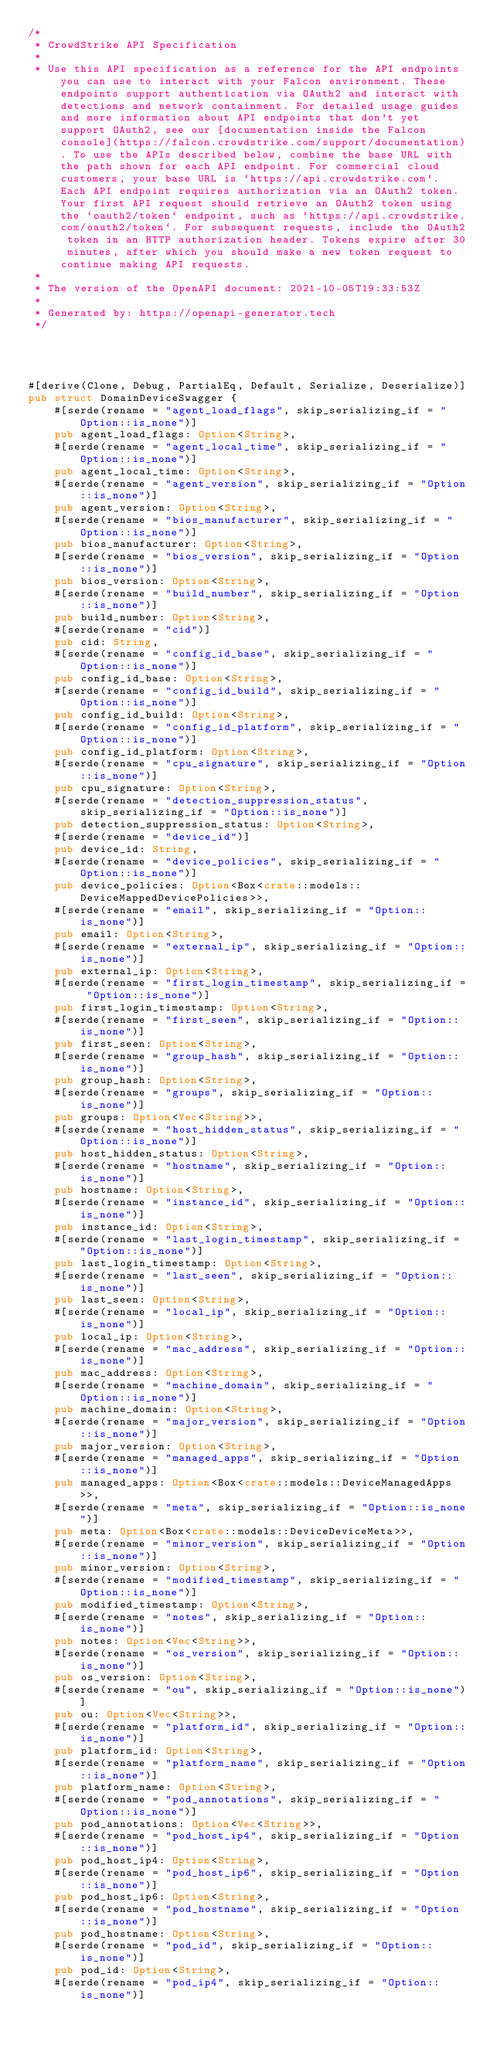Convert code to text. <code><loc_0><loc_0><loc_500><loc_500><_Rust_>/*
 * CrowdStrike API Specification
 *
 * Use this API specification as a reference for the API endpoints you can use to interact with your Falcon environment. These endpoints support authentication via OAuth2 and interact with detections and network containment. For detailed usage guides and more information about API endpoints that don't yet support OAuth2, see our [documentation inside the Falcon console](https://falcon.crowdstrike.com/support/documentation). To use the APIs described below, combine the base URL with the path shown for each API endpoint. For commercial cloud customers, your base URL is `https://api.crowdstrike.com`. Each API endpoint requires authorization via an OAuth2 token. Your first API request should retrieve an OAuth2 token using the `oauth2/token` endpoint, such as `https://api.crowdstrike.com/oauth2/token`. For subsequent requests, include the OAuth2 token in an HTTP authorization header. Tokens expire after 30 minutes, after which you should make a new token request to continue making API requests.
 *
 * The version of the OpenAPI document: 2021-10-05T19:33:53Z
 * 
 * Generated by: https://openapi-generator.tech
 */




#[derive(Clone, Debug, PartialEq, Default, Serialize, Deserialize)]
pub struct DomainDeviceSwagger {
    #[serde(rename = "agent_load_flags", skip_serializing_if = "Option::is_none")]
    pub agent_load_flags: Option<String>,
    #[serde(rename = "agent_local_time", skip_serializing_if = "Option::is_none")]
    pub agent_local_time: Option<String>,
    #[serde(rename = "agent_version", skip_serializing_if = "Option::is_none")]
    pub agent_version: Option<String>,
    #[serde(rename = "bios_manufacturer", skip_serializing_if = "Option::is_none")]
    pub bios_manufacturer: Option<String>,
    #[serde(rename = "bios_version", skip_serializing_if = "Option::is_none")]
    pub bios_version: Option<String>,
    #[serde(rename = "build_number", skip_serializing_if = "Option::is_none")]
    pub build_number: Option<String>,
    #[serde(rename = "cid")]
    pub cid: String,
    #[serde(rename = "config_id_base", skip_serializing_if = "Option::is_none")]
    pub config_id_base: Option<String>,
    #[serde(rename = "config_id_build", skip_serializing_if = "Option::is_none")]
    pub config_id_build: Option<String>,
    #[serde(rename = "config_id_platform", skip_serializing_if = "Option::is_none")]
    pub config_id_platform: Option<String>,
    #[serde(rename = "cpu_signature", skip_serializing_if = "Option::is_none")]
    pub cpu_signature: Option<String>,
    #[serde(rename = "detection_suppression_status", skip_serializing_if = "Option::is_none")]
    pub detection_suppression_status: Option<String>,
    #[serde(rename = "device_id")]
    pub device_id: String,
    #[serde(rename = "device_policies", skip_serializing_if = "Option::is_none")]
    pub device_policies: Option<Box<crate::models::DeviceMappedDevicePolicies>>,
    #[serde(rename = "email", skip_serializing_if = "Option::is_none")]
    pub email: Option<String>,
    #[serde(rename = "external_ip", skip_serializing_if = "Option::is_none")]
    pub external_ip: Option<String>,
    #[serde(rename = "first_login_timestamp", skip_serializing_if = "Option::is_none")]
    pub first_login_timestamp: Option<String>,
    #[serde(rename = "first_seen", skip_serializing_if = "Option::is_none")]
    pub first_seen: Option<String>,
    #[serde(rename = "group_hash", skip_serializing_if = "Option::is_none")]
    pub group_hash: Option<String>,
    #[serde(rename = "groups", skip_serializing_if = "Option::is_none")]
    pub groups: Option<Vec<String>>,
    #[serde(rename = "host_hidden_status", skip_serializing_if = "Option::is_none")]
    pub host_hidden_status: Option<String>,
    #[serde(rename = "hostname", skip_serializing_if = "Option::is_none")]
    pub hostname: Option<String>,
    #[serde(rename = "instance_id", skip_serializing_if = "Option::is_none")]
    pub instance_id: Option<String>,
    #[serde(rename = "last_login_timestamp", skip_serializing_if = "Option::is_none")]
    pub last_login_timestamp: Option<String>,
    #[serde(rename = "last_seen", skip_serializing_if = "Option::is_none")]
    pub last_seen: Option<String>,
    #[serde(rename = "local_ip", skip_serializing_if = "Option::is_none")]
    pub local_ip: Option<String>,
    #[serde(rename = "mac_address", skip_serializing_if = "Option::is_none")]
    pub mac_address: Option<String>,
    #[serde(rename = "machine_domain", skip_serializing_if = "Option::is_none")]
    pub machine_domain: Option<String>,
    #[serde(rename = "major_version", skip_serializing_if = "Option::is_none")]
    pub major_version: Option<String>,
    #[serde(rename = "managed_apps", skip_serializing_if = "Option::is_none")]
    pub managed_apps: Option<Box<crate::models::DeviceManagedApps>>,
    #[serde(rename = "meta", skip_serializing_if = "Option::is_none")]
    pub meta: Option<Box<crate::models::DeviceDeviceMeta>>,
    #[serde(rename = "minor_version", skip_serializing_if = "Option::is_none")]
    pub minor_version: Option<String>,
    #[serde(rename = "modified_timestamp", skip_serializing_if = "Option::is_none")]
    pub modified_timestamp: Option<String>,
    #[serde(rename = "notes", skip_serializing_if = "Option::is_none")]
    pub notes: Option<Vec<String>>,
    #[serde(rename = "os_version", skip_serializing_if = "Option::is_none")]
    pub os_version: Option<String>,
    #[serde(rename = "ou", skip_serializing_if = "Option::is_none")]
    pub ou: Option<Vec<String>>,
    #[serde(rename = "platform_id", skip_serializing_if = "Option::is_none")]
    pub platform_id: Option<String>,
    #[serde(rename = "platform_name", skip_serializing_if = "Option::is_none")]
    pub platform_name: Option<String>,
    #[serde(rename = "pod_annotations", skip_serializing_if = "Option::is_none")]
    pub pod_annotations: Option<Vec<String>>,
    #[serde(rename = "pod_host_ip4", skip_serializing_if = "Option::is_none")]
    pub pod_host_ip4: Option<String>,
    #[serde(rename = "pod_host_ip6", skip_serializing_if = "Option::is_none")]
    pub pod_host_ip6: Option<String>,
    #[serde(rename = "pod_hostname", skip_serializing_if = "Option::is_none")]
    pub pod_hostname: Option<String>,
    #[serde(rename = "pod_id", skip_serializing_if = "Option::is_none")]
    pub pod_id: Option<String>,
    #[serde(rename = "pod_ip4", skip_serializing_if = "Option::is_none")]</code> 